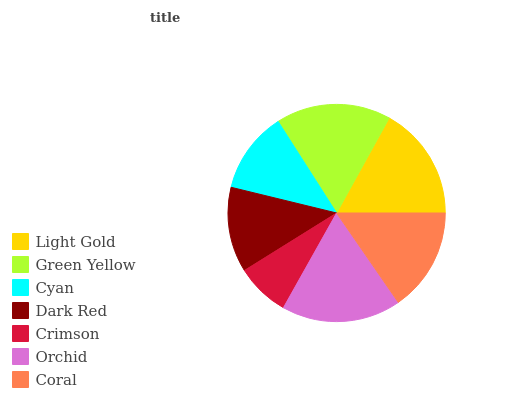Is Crimson the minimum?
Answer yes or no. Yes. Is Orchid the maximum?
Answer yes or no. Yes. Is Green Yellow the minimum?
Answer yes or no. No. Is Green Yellow the maximum?
Answer yes or no. No. Is Green Yellow greater than Light Gold?
Answer yes or no. Yes. Is Light Gold less than Green Yellow?
Answer yes or no. Yes. Is Light Gold greater than Green Yellow?
Answer yes or no. No. Is Green Yellow less than Light Gold?
Answer yes or no. No. Is Coral the high median?
Answer yes or no. Yes. Is Coral the low median?
Answer yes or no. Yes. Is Green Yellow the high median?
Answer yes or no. No. Is Light Gold the low median?
Answer yes or no. No. 